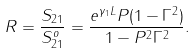<formula> <loc_0><loc_0><loc_500><loc_500>R = \frac { S _ { 2 1 } } { S _ { 2 1 } ^ { o } } = \frac { e ^ { \gamma _ { 1 } L } P ( 1 - \Gamma ^ { 2 } ) } { 1 - P ^ { 2 } \Gamma ^ { 2 } } .</formula> 